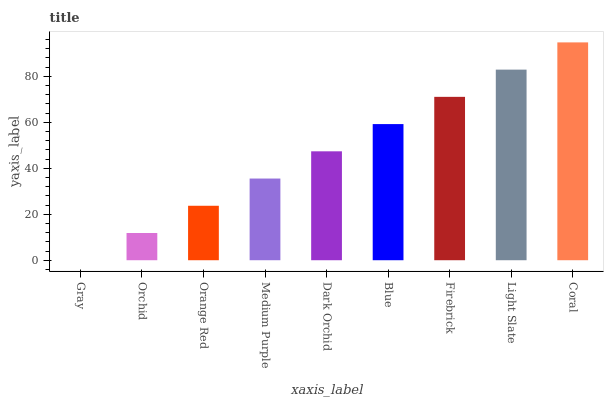Is Gray the minimum?
Answer yes or no. Yes. Is Coral the maximum?
Answer yes or no. Yes. Is Orchid the minimum?
Answer yes or no. No. Is Orchid the maximum?
Answer yes or no. No. Is Orchid greater than Gray?
Answer yes or no. Yes. Is Gray less than Orchid?
Answer yes or no. Yes. Is Gray greater than Orchid?
Answer yes or no. No. Is Orchid less than Gray?
Answer yes or no. No. Is Dark Orchid the high median?
Answer yes or no. Yes. Is Dark Orchid the low median?
Answer yes or no. Yes. Is Light Slate the high median?
Answer yes or no. No. Is Blue the low median?
Answer yes or no. No. 